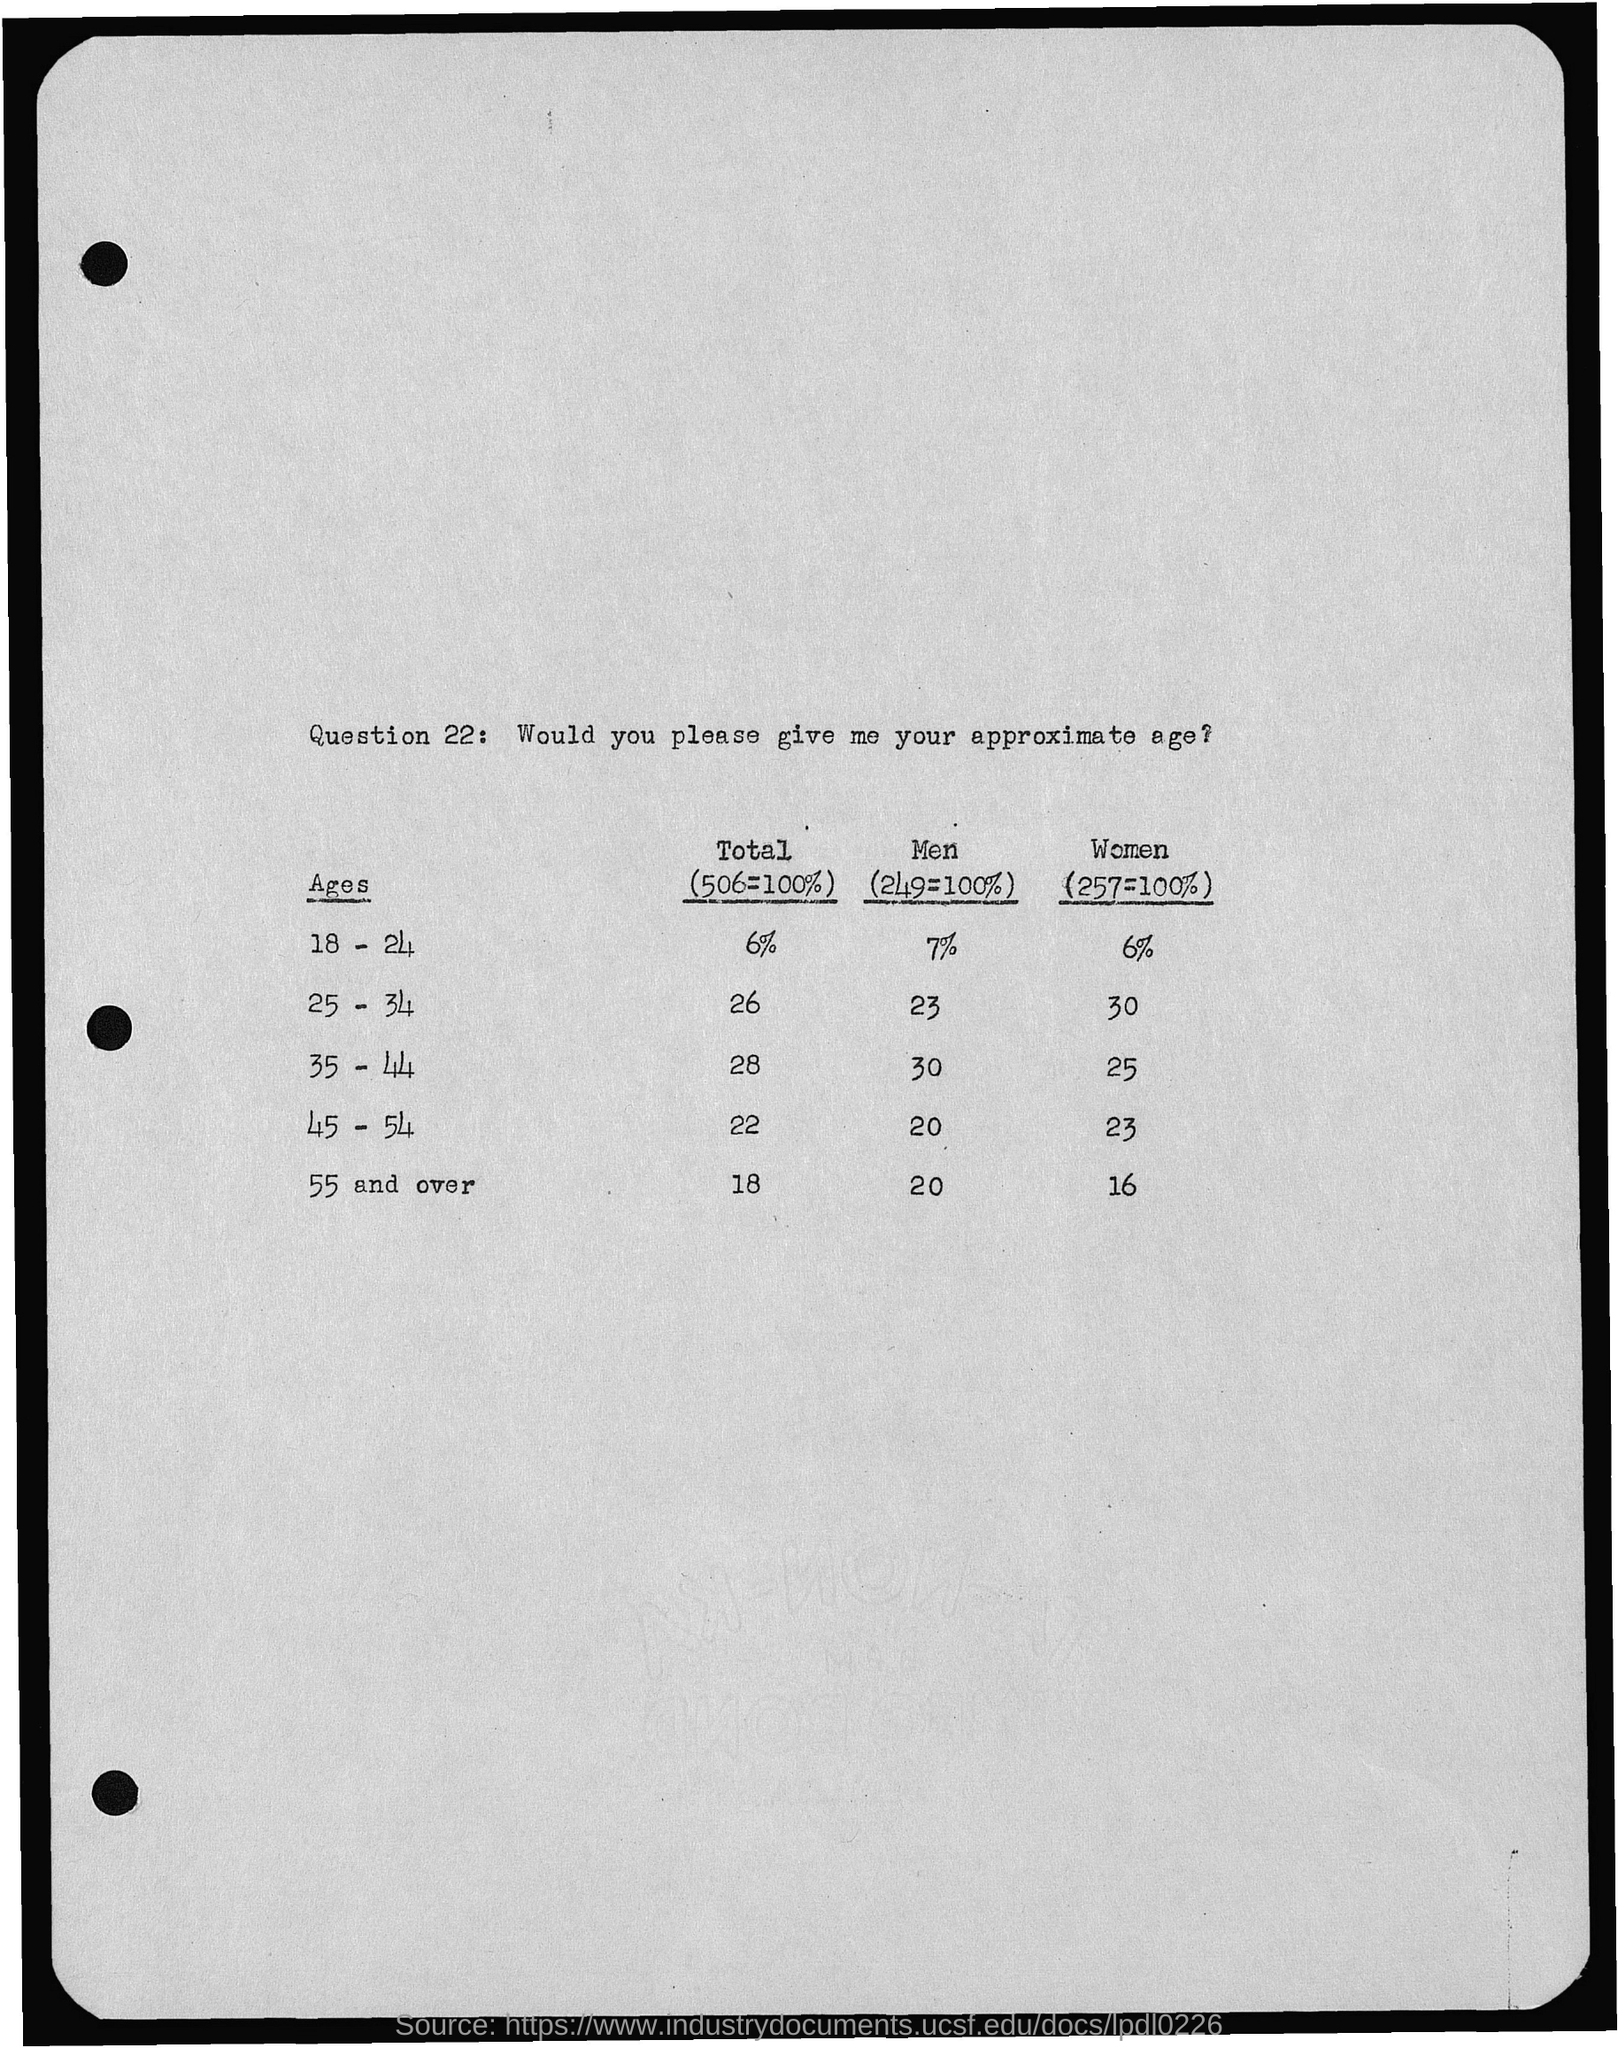Point out several critical features in this image. The total for ages 45 to 54 is 22. The total for ages 18-24 is 6%. The total for ages 25-34 is 26. The total for ages 35 to 44 is 28. 